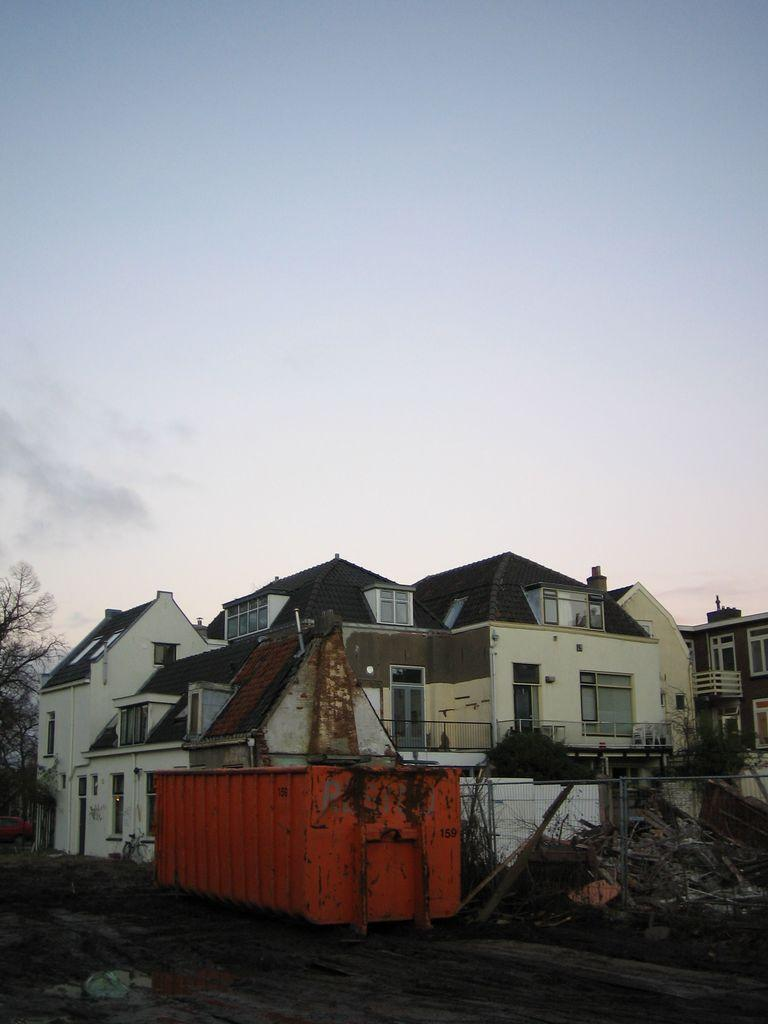What type of structures are located at the bottom of the image? There are buildings at the bottom of the image. What can be seen on the left side of the image? There are trees on the left side of the image. What is present on the right side of the image? There are trees on the right side of the image. What is visible at the top of the image? The sky is at the top of the image. How many laborers are working in the trees on the left side of the image? There are no laborers present in the image; it only features trees and buildings. What type of clam can be seen crawling on the buildings at the bottom of the image? There are no clams present in the image; it only features buildings and trees. 